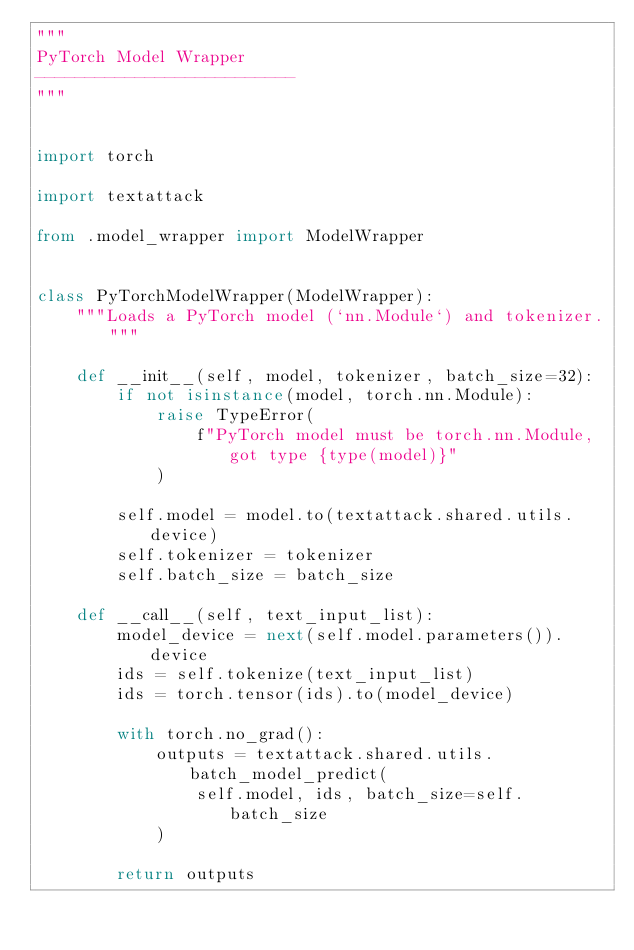<code> <loc_0><loc_0><loc_500><loc_500><_Python_>"""
PyTorch Model Wrapper
--------------------------
"""


import torch

import textattack

from .model_wrapper import ModelWrapper


class PyTorchModelWrapper(ModelWrapper):
    """Loads a PyTorch model (`nn.Module`) and tokenizer."""

    def __init__(self, model, tokenizer, batch_size=32):
        if not isinstance(model, torch.nn.Module):
            raise TypeError(
                f"PyTorch model must be torch.nn.Module, got type {type(model)}"
            )

        self.model = model.to(textattack.shared.utils.device)
        self.tokenizer = tokenizer
        self.batch_size = batch_size

    def __call__(self, text_input_list):
        model_device = next(self.model.parameters()).device
        ids = self.tokenize(text_input_list)
        ids = torch.tensor(ids).to(model_device)

        with torch.no_grad():
            outputs = textattack.shared.utils.batch_model_predict(
                self.model, ids, batch_size=self.batch_size
            )

        return outputs
</code> 